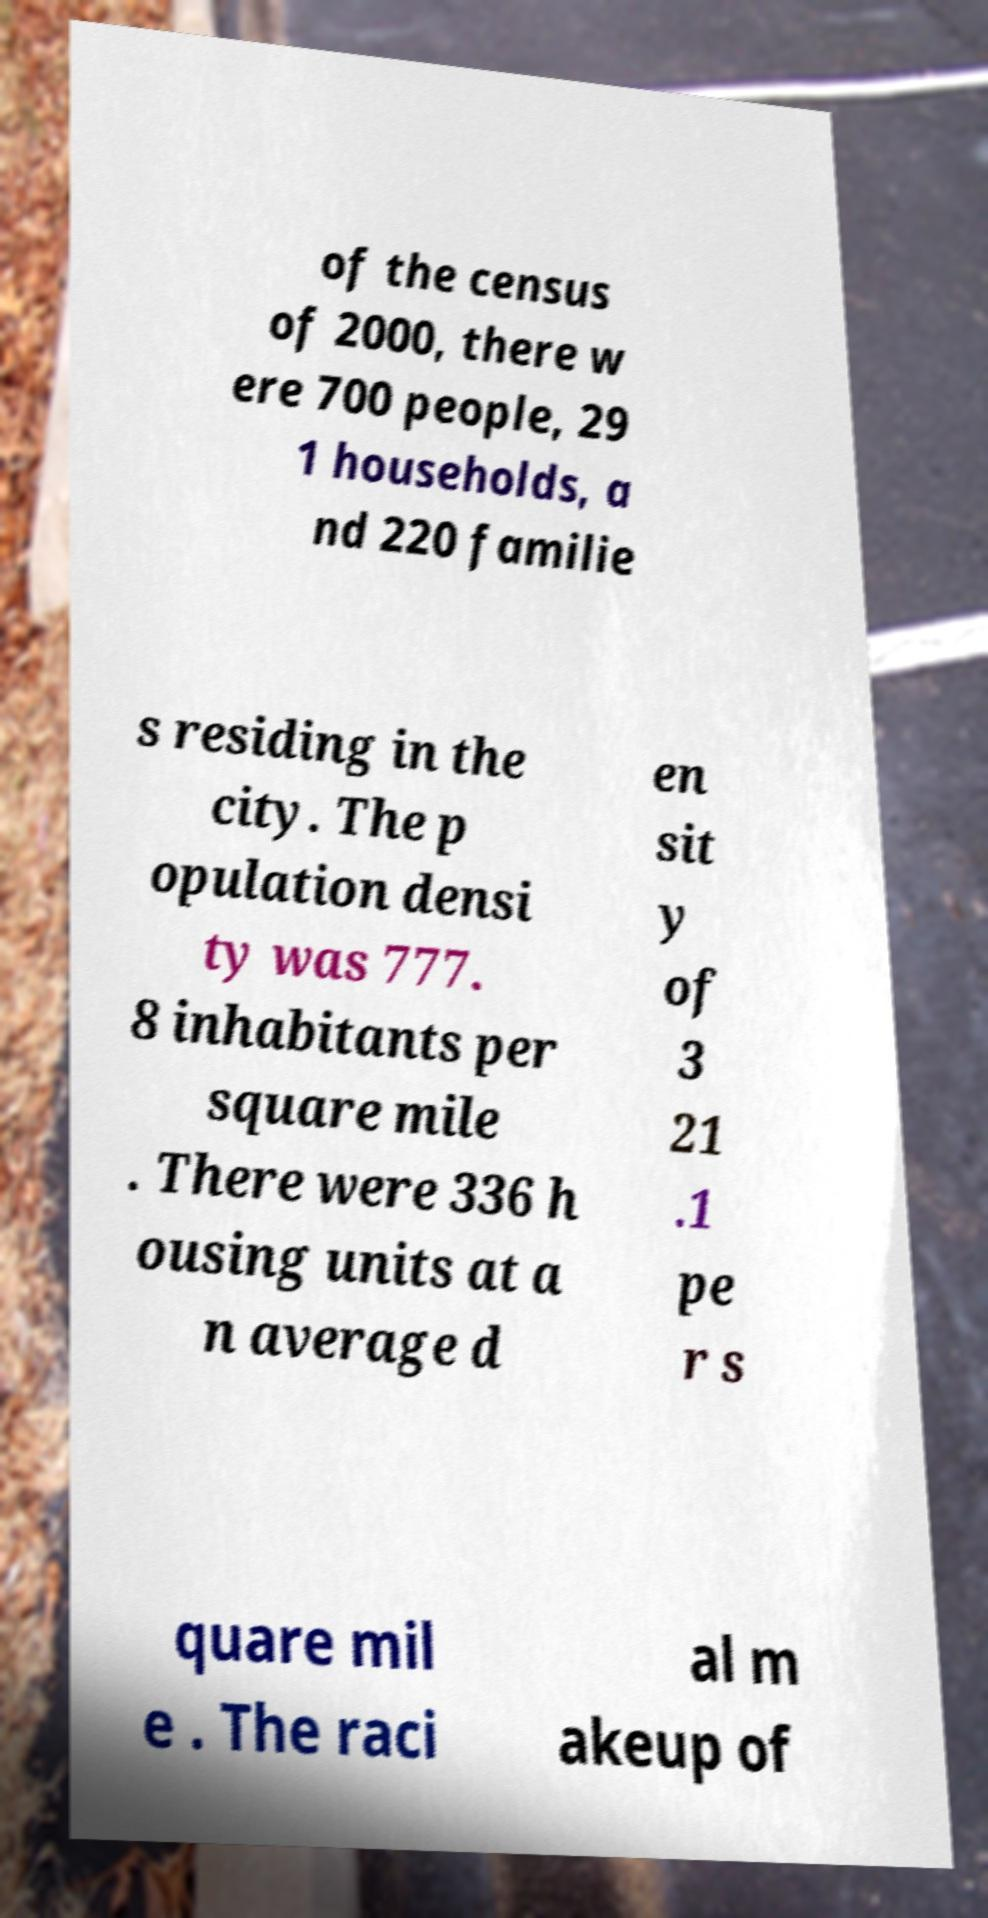Please read and relay the text visible in this image. What does it say? of the census of 2000, there w ere 700 people, 29 1 households, a nd 220 familie s residing in the city. The p opulation densi ty was 777. 8 inhabitants per square mile . There were 336 h ousing units at a n average d en sit y of 3 21 .1 pe r s quare mil e . The raci al m akeup of 